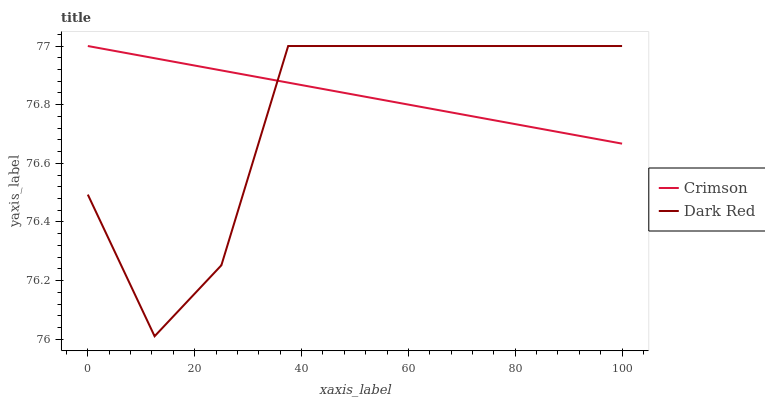Does Dark Red have the minimum area under the curve?
Answer yes or no. Yes. Does Crimson have the maximum area under the curve?
Answer yes or no. Yes. Does Dark Red have the maximum area under the curve?
Answer yes or no. No. Is Crimson the smoothest?
Answer yes or no. Yes. Is Dark Red the roughest?
Answer yes or no. Yes. Is Dark Red the smoothest?
Answer yes or no. No. Does Dark Red have the lowest value?
Answer yes or no. Yes. Does Dark Red have the highest value?
Answer yes or no. Yes. Does Dark Red intersect Crimson?
Answer yes or no. Yes. Is Dark Red less than Crimson?
Answer yes or no. No. Is Dark Red greater than Crimson?
Answer yes or no. No. 